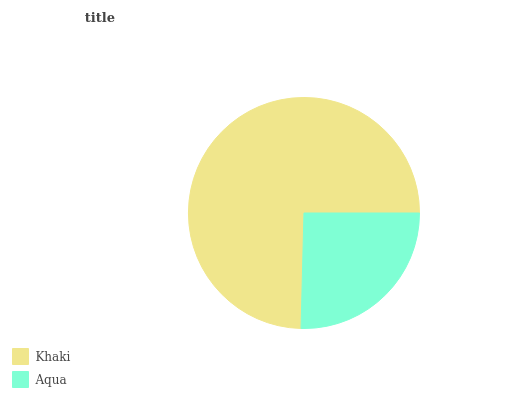Is Aqua the minimum?
Answer yes or no. Yes. Is Khaki the maximum?
Answer yes or no. Yes. Is Aqua the maximum?
Answer yes or no. No. Is Khaki greater than Aqua?
Answer yes or no. Yes. Is Aqua less than Khaki?
Answer yes or no. Yes. Is Aqua greater than Khaki?
Answer yes or no. No. Is Khaki less than Aqua?
Answer yes or no. No. Is Khaki the high median?
Answer yes or no. Yes. Is Aqua the low median?
Answer yes or no. Yes. Is Aqua the high median?
Answer yes or no. No. Is Khaki the low median?
Answer yes or no. No. 